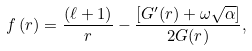<formula> <loc_0><loc_0><loc_500><loc_500>f \left ( r \right ) = \frac { \left ( \ell + 1 \right ) } { r } - \frac { \left [ G ^ { \prime } ( r ) + \omega \sqrt { \alpha } \right ] } { 2 G ( r ) } ,</formula> 